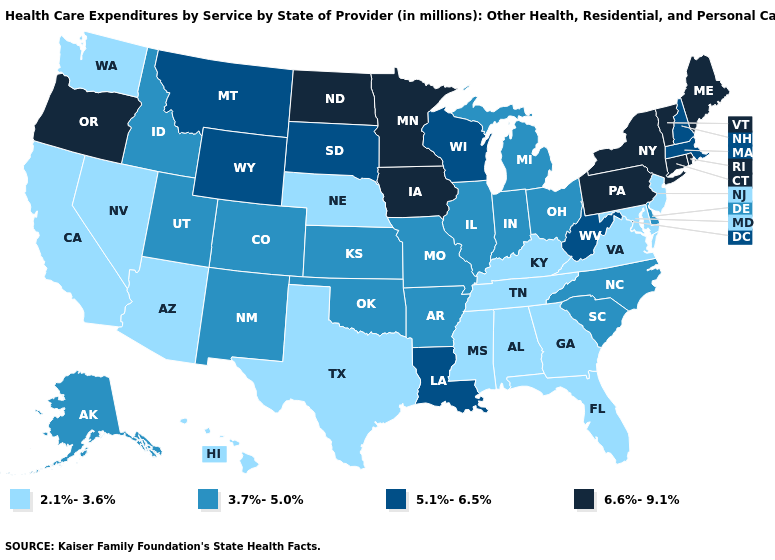Does New Jersey have the highest value in the Northeast?
Answer briefly. No. Among the states that border Rhode Island , which have the lowest value?
Quick response, please. Massachusetts. Does the map have missing data?
Concise answer only. No. Does the first symbol in the legend represent the smallest category?
Short answer required. Yes. What is the value of Wisconsin?
Quick response, please. 5.1%-6.5%. Which states have the lowest value in the Northeast?
Write a very short answer. New Jersey. Which states have the lowest value in the West?
Quick response, please. Arizona, California, Hawaii, Nevada, Washington. What is the lowest value in the Northeast?
Quick response, please. 2.1%-3.6%. What is the value of Illinois?
Concise answer only. 3.7%-5.0%. Among the states that border Kentucky , does West Virginia have the highest value?
Give a very brief answer. Yes. Among the states that border Colorado , which have the lowest value?
Give a very brief answer. Arizona, Nebraska. What is the lowest value in states that border Florida?
Quick response, please. 2.1%-3.6%. How many symbols are there in the legend?
Quick response, please. 4. Is the legend a continuous bar?
Concise answer only. No. What is the value of Mississippi?
Be succinct. 2.1%-3.6%. 